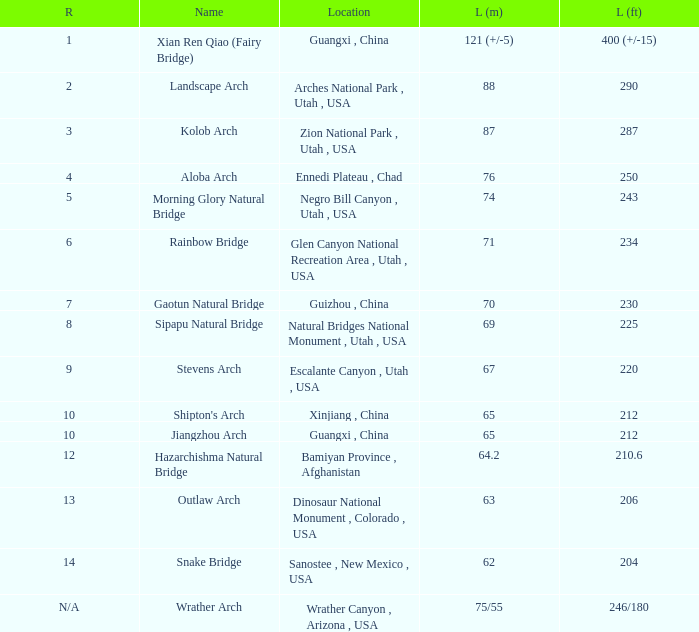What is the length in feet when the length in meters is 64.2? 210.6. 